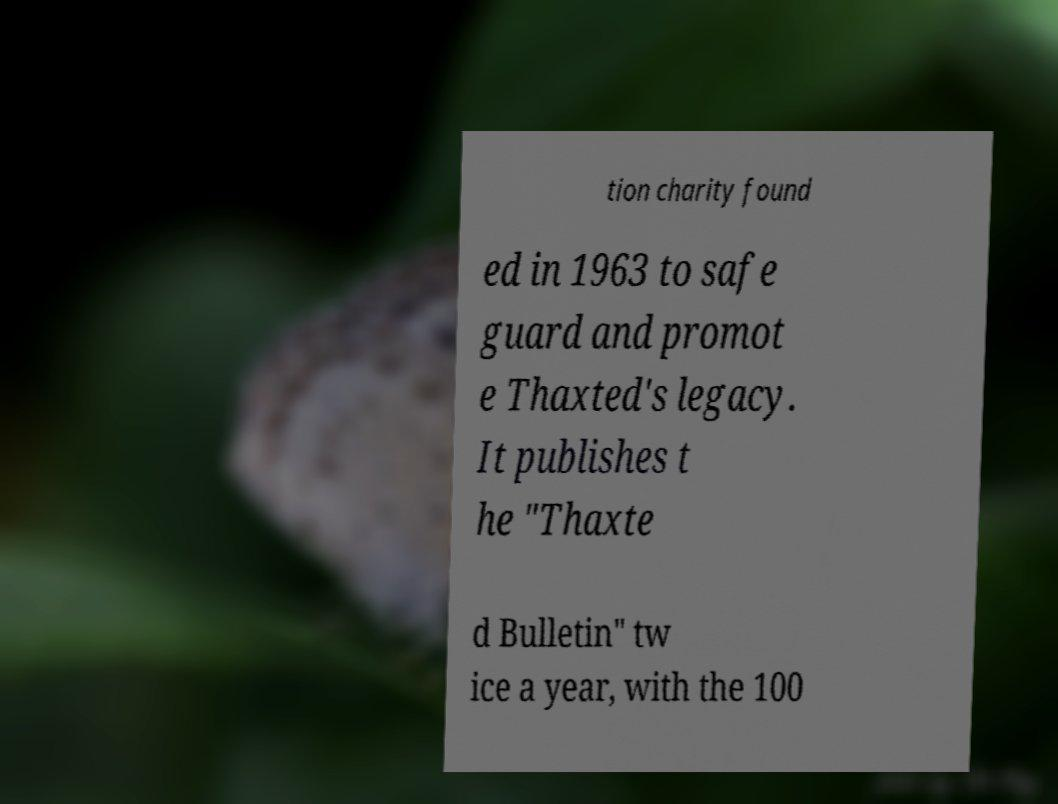For documentation purposes, I need the text within this image transcribed. Could you provide that? tion charity found ed in 1963 to safe guard and promot e Thaxted's legacy. It publishes t he "Thaxte d Bulletin" tw ice a year, with the 100 